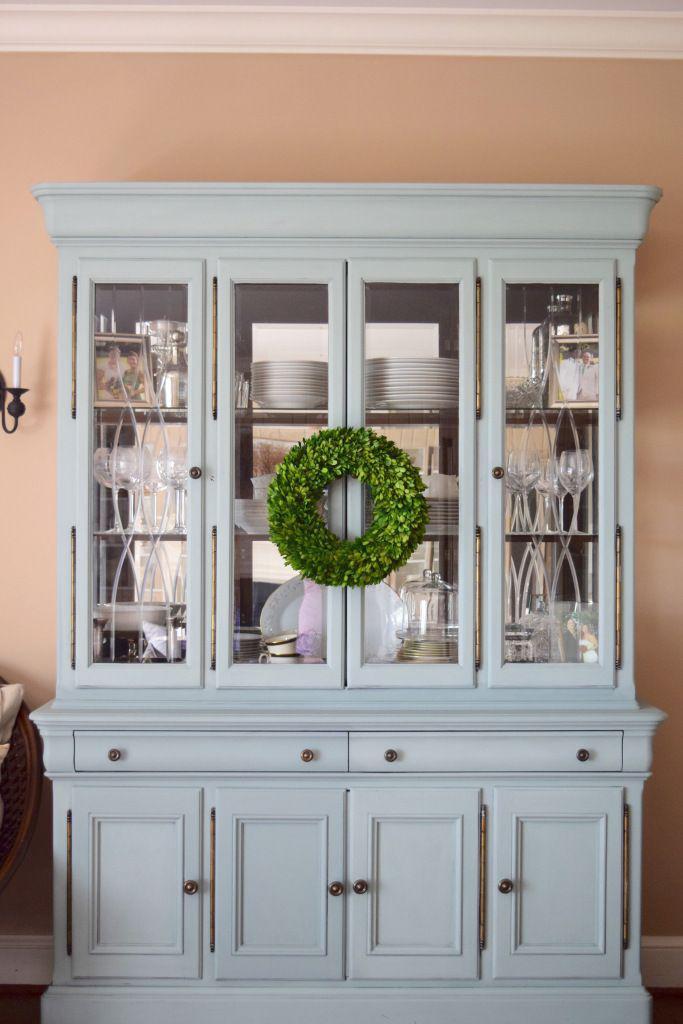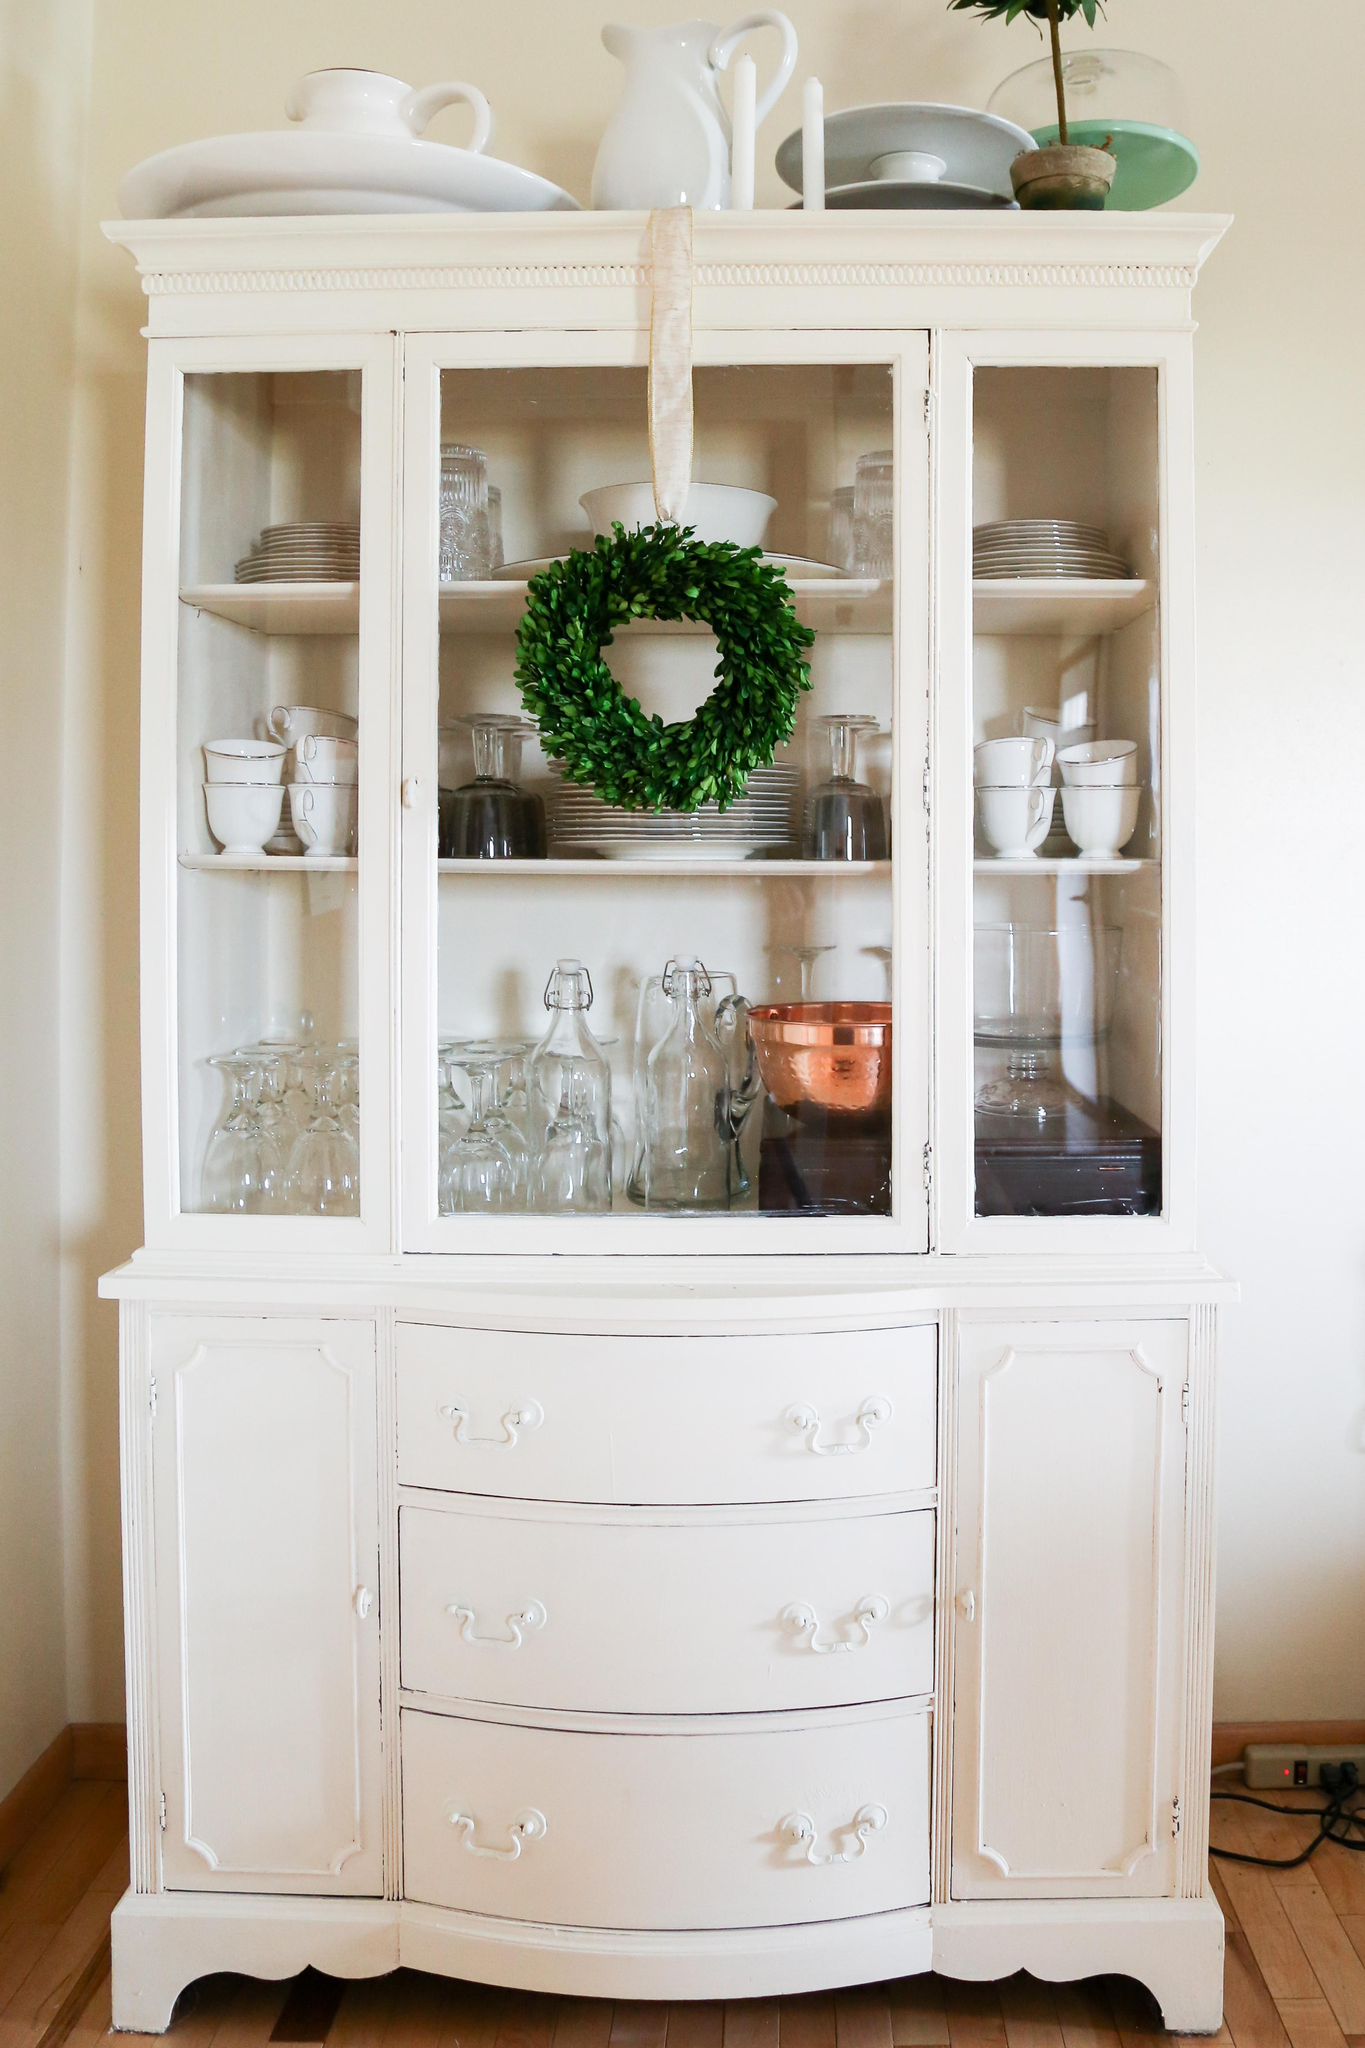The first image is the image on the left, the second image is the image on the right. Evaluate the accuracy of this statement regarding the images: "A blue hutch in one image has four glass doors and four lower panel doors, and is wider than a white hutch with glass doors in the second image.". Is it true? Answer yes or no. Yes. The first image is the image on the left, the second image is the image on the right. Given the left and right images, does the statement "one of the hutch is white" hold true? Answer yes or no. Yes. The first image is the image on the left, the second image is the image on the right. Considering the images on both sides, is "Two painted hutches are different widths, with one sitting flush to the floor and the other with open space above the floor." valid? Answer yes or no. Yes. The first image is the image on the left, the second image is the image on the right. Considering the images on both sides, is "One cabinet has a curved top with a fleur-de-lis design, and scrollwork at the footed base." valid? Answer yes or no. No. 